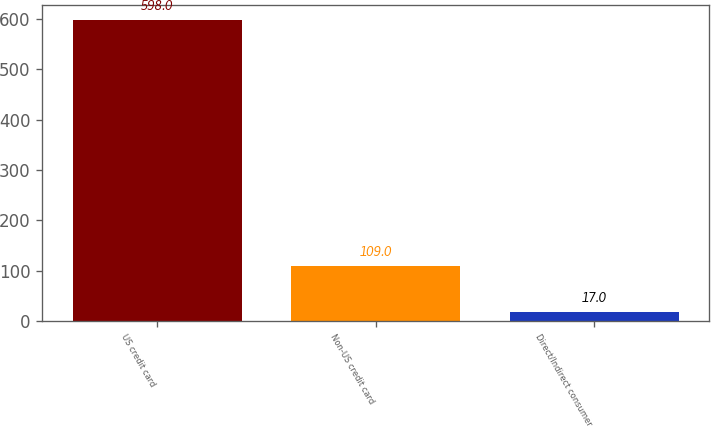<chart> <loc_0><loc_0><loc_500><loc_500><bar_chart><fcel>US credit card<fcel>Non-US credit card<fcel>Direct/Indirect consumer<nl><fcel>598<fcel>109<fcel>17<nl></chart> 